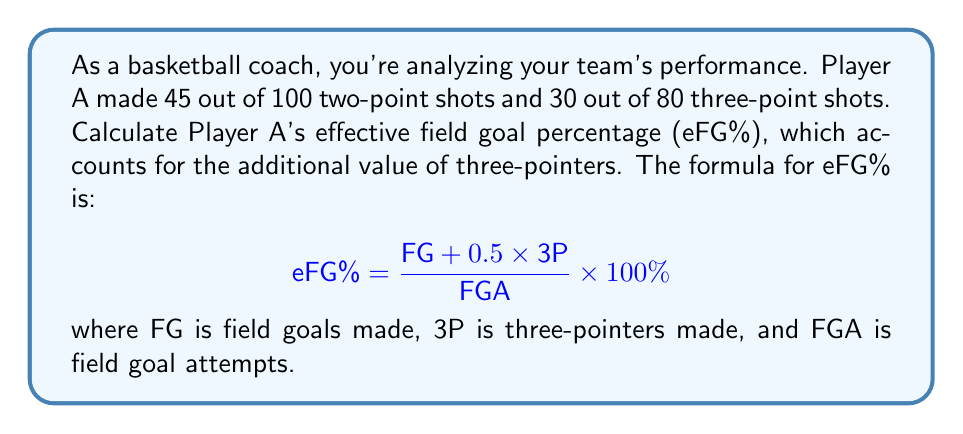Can you answer this question? Let's break this down step-by-step:

1. Identify the given information:
   - Two-point shots: 45 made out of 100 attempts
   - Three-point shots: 30 made out of 80 attempts

2. Calculate total field goals (FG) made:
   $FG = 45 + 30 = 75$

3. Calculate total field goal attempts (FGA):
   $FGA = 100 + 80 = 180$

4. Apply the eFG% formula:
   $$ \text{eFG%} = \frac{\text{FG} + 0.5 \times \text{3P}}{\text{FGA}} \times 100\% $$

   Substituting the values:
   $$ \text{eFG%} = \frac{75 + 0.5 \times 30}{180} \times 100\% $$

5. Simplify:
   $$ \text{eFG%} = \frac{75 + 15}{180} \times 100\% = \frac{90}{180} \times 100\% = 0.5 \times 100\% = 50\% $$

Therefore, Player A's effective field goal percentage is 50%.
Answer: 50% 